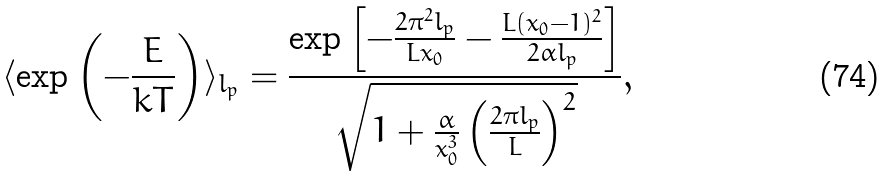<formula> <loc_0><loc_0><loc_500><loc_500>\langle \exp \left ( - \frac { E } { k T } \right ) \rangle _ { l _ { p } } = \frac { \exp \left [ - \frac { 2 \pi ^ { 2 } l _ { p } } { L x _ { 0 } } - \frac { L ( x _ { 0 } - 1 ) ^ { 2 } } { 2 \alpha l _ { p } } \right ] } { \sqrt { 1 + \frac { \alpha } { x _ { 0 } ^ { 3 } } \left ( \frac { 2 \pi l _ { p } } { L } \right ) ^ { 2 } } } ,</formula> 